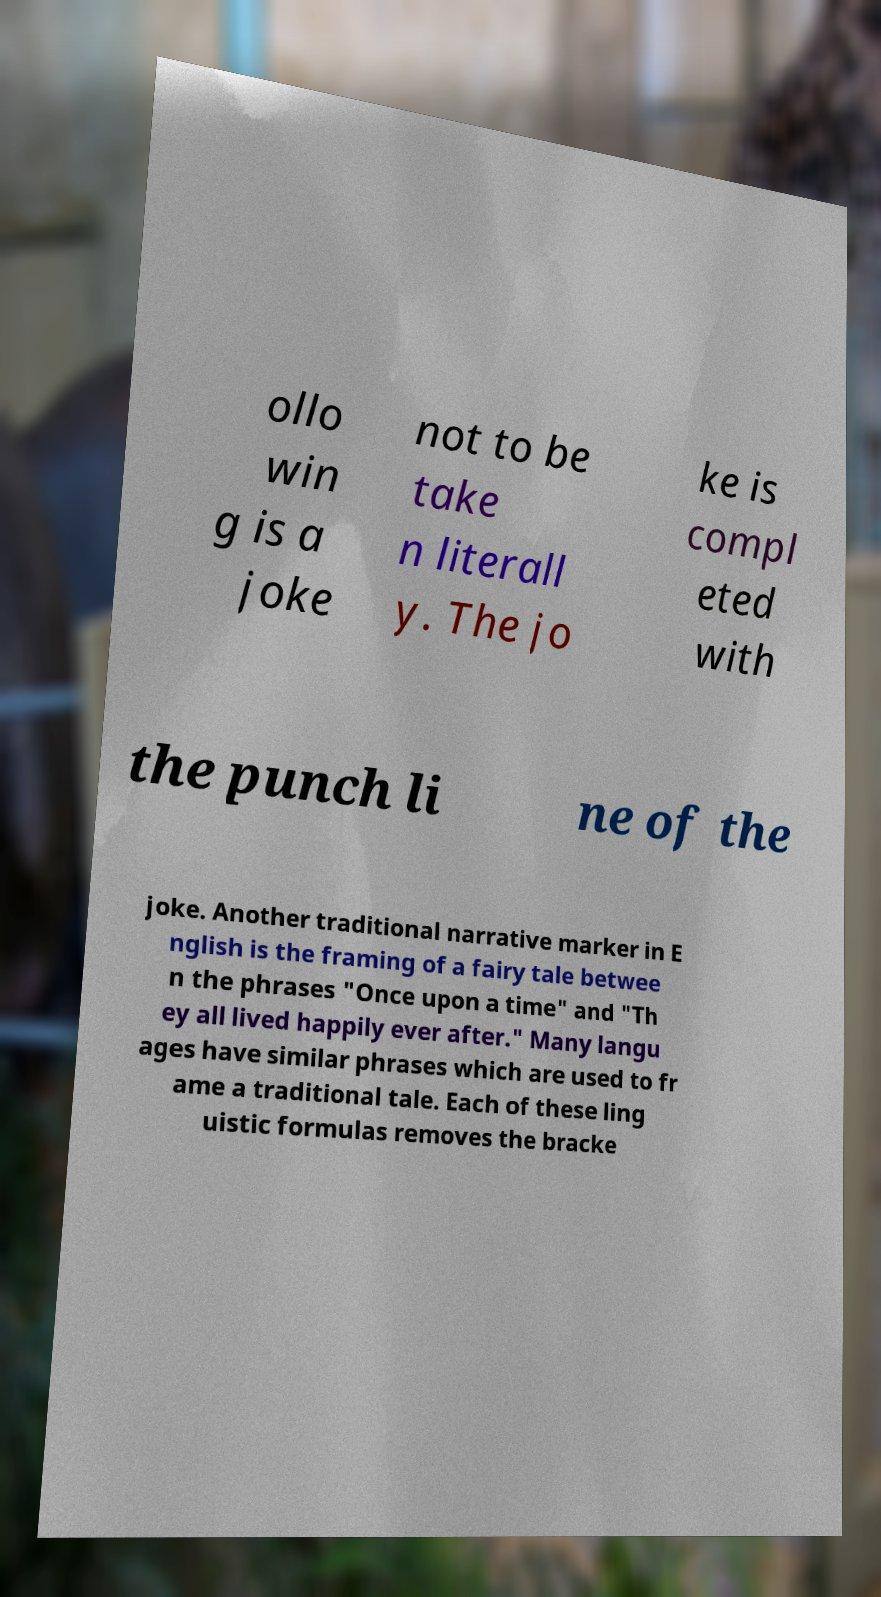Could you extract and type out the text from this image? ollo win g is a joke not to be take n literall y. The jo ke is compl eted with the punch li ne of the joke. Another traditional narrative marker in E nglish is the framing of a fairy tale betwee n the phrases "Once upon a time" and "Th ey all lived happily ever after." Many langu ages have similar phrases which are used to fr ame a traditional tale. Each of these ling uistic formulas removes the bracke 